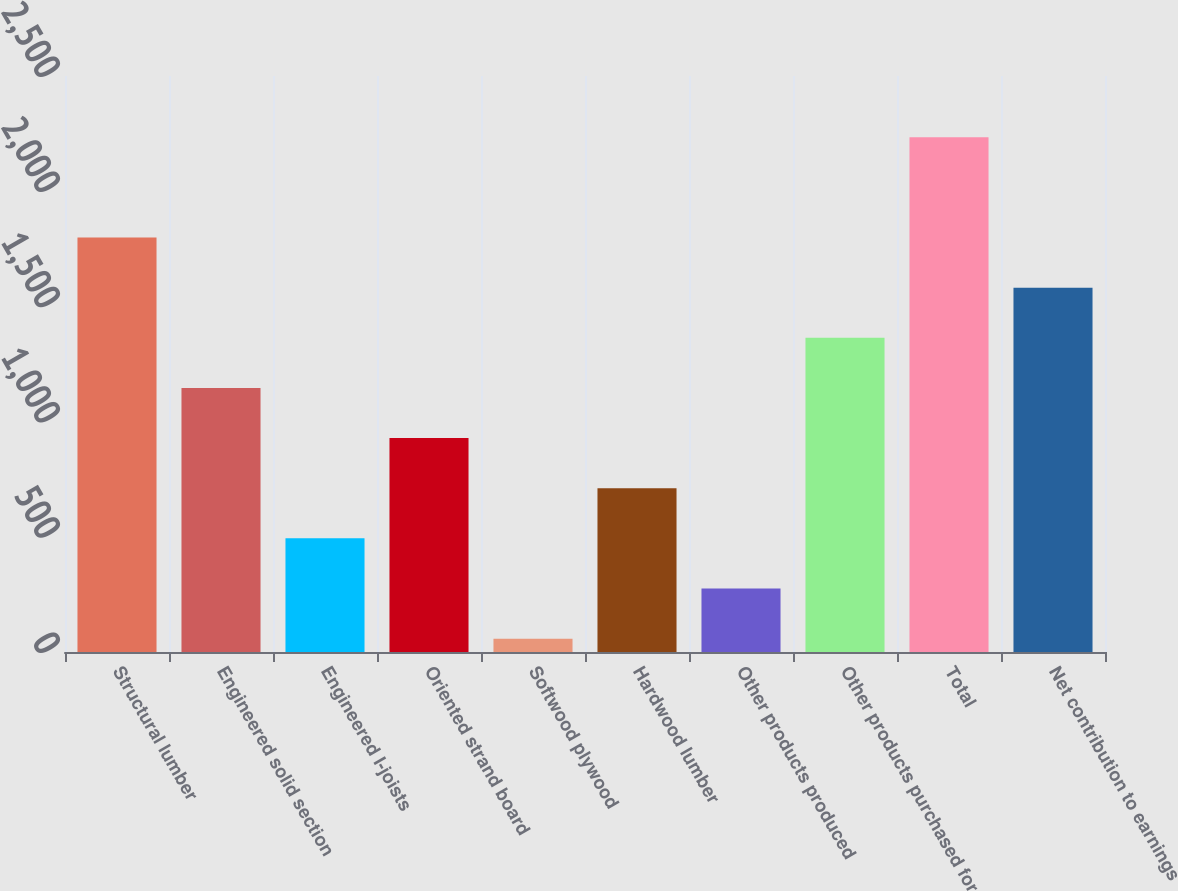Convert chart. <chart><loc_0><loc_0><loc_500><loc_500><bar_chart><fcel>Structural lumber<fcel>Engineered solid section<fcel>Engineered I-joists<fcel>Oriented strand board<fcel>Softwood plywood<fcel>Hardwood lumber<fcel>Other products produced<fcel>Other products purchased for<fcel>Total<fcel>Net contribution to earnings<nl><fcel>1798.8<fcel>1146<fcel>493.2<fcel>928.4<fcel>58<fcel>710.8<fcel>275.6<fcel>1363.6<fcel>2234<fcel>1581.2<nl></chart> 